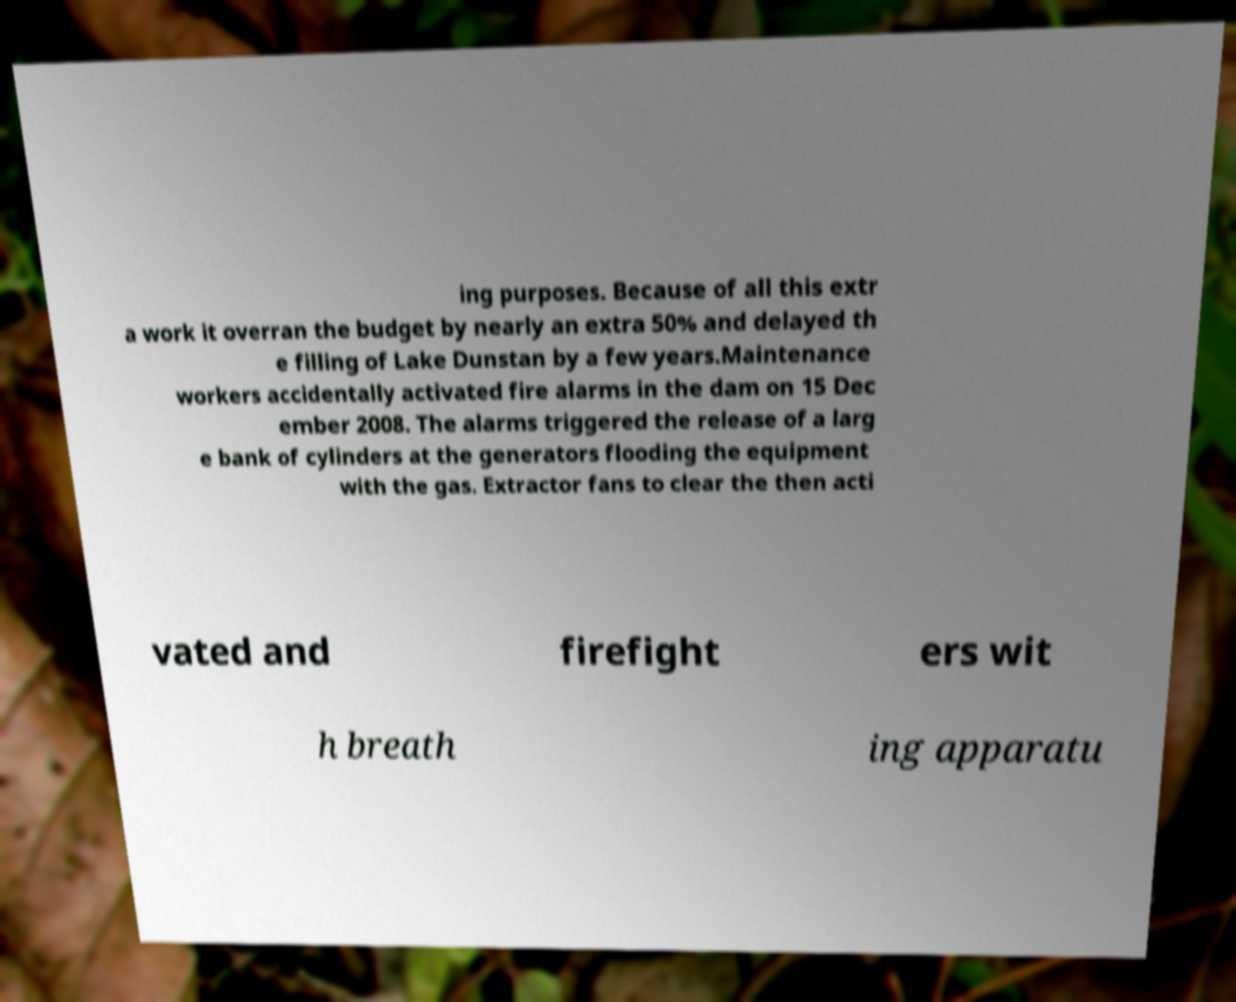For documentation purposes, I need the text within this image transcribed. Could you provide that? ing purposes. Because of all this extr a work it overran the budget by nearly an extra 50% and delayed th e filling of Lake Dunstan by a few years.Maintenance workers accidentally activated fire alarms in the dam on 15 Dec ember 2008. The alarms triggered the release of a larg e bank of cylinders at the generators flooding the equipment with the gas. Extractor fans to clear the then acti vated and firefight ers wit h breath ing apparatu 